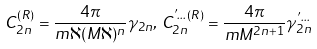Convert formula to latex. <formula><loc_0><loc_0><loc_500><loc_500>C _ { 2 n } ^ { ( R ) } = \frac { 4 \pi } { m \aleph ( M \aleph ) ^ { n } } \gamma _ { 2 n } , \, C _ { 2 n } ^ { ^ { \prime } \dots ( R ) } = \frac { 4 \pi } { m M ^ { 2 n + 1 } } \gamma ^ { ^ { \prime } \dots } _ { 2 n }</formula> 